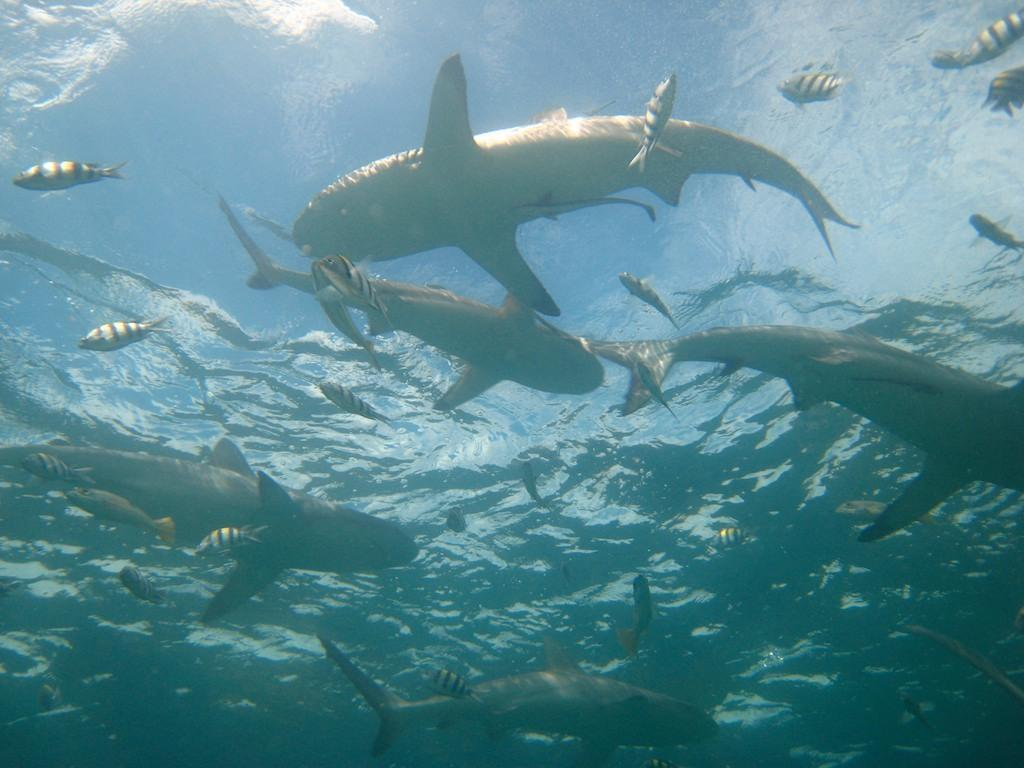What type of animals can be seen in the image? There are many fishes in the image. Where are the fishes located? The fishes are in the water. What type of beetle can be seen in the image? There are no beetles present in the image; it features many fishes in the water. What type of farming equipment can be seen in the image? There is no farming equipment present in the image; it features many fishes in the water. 